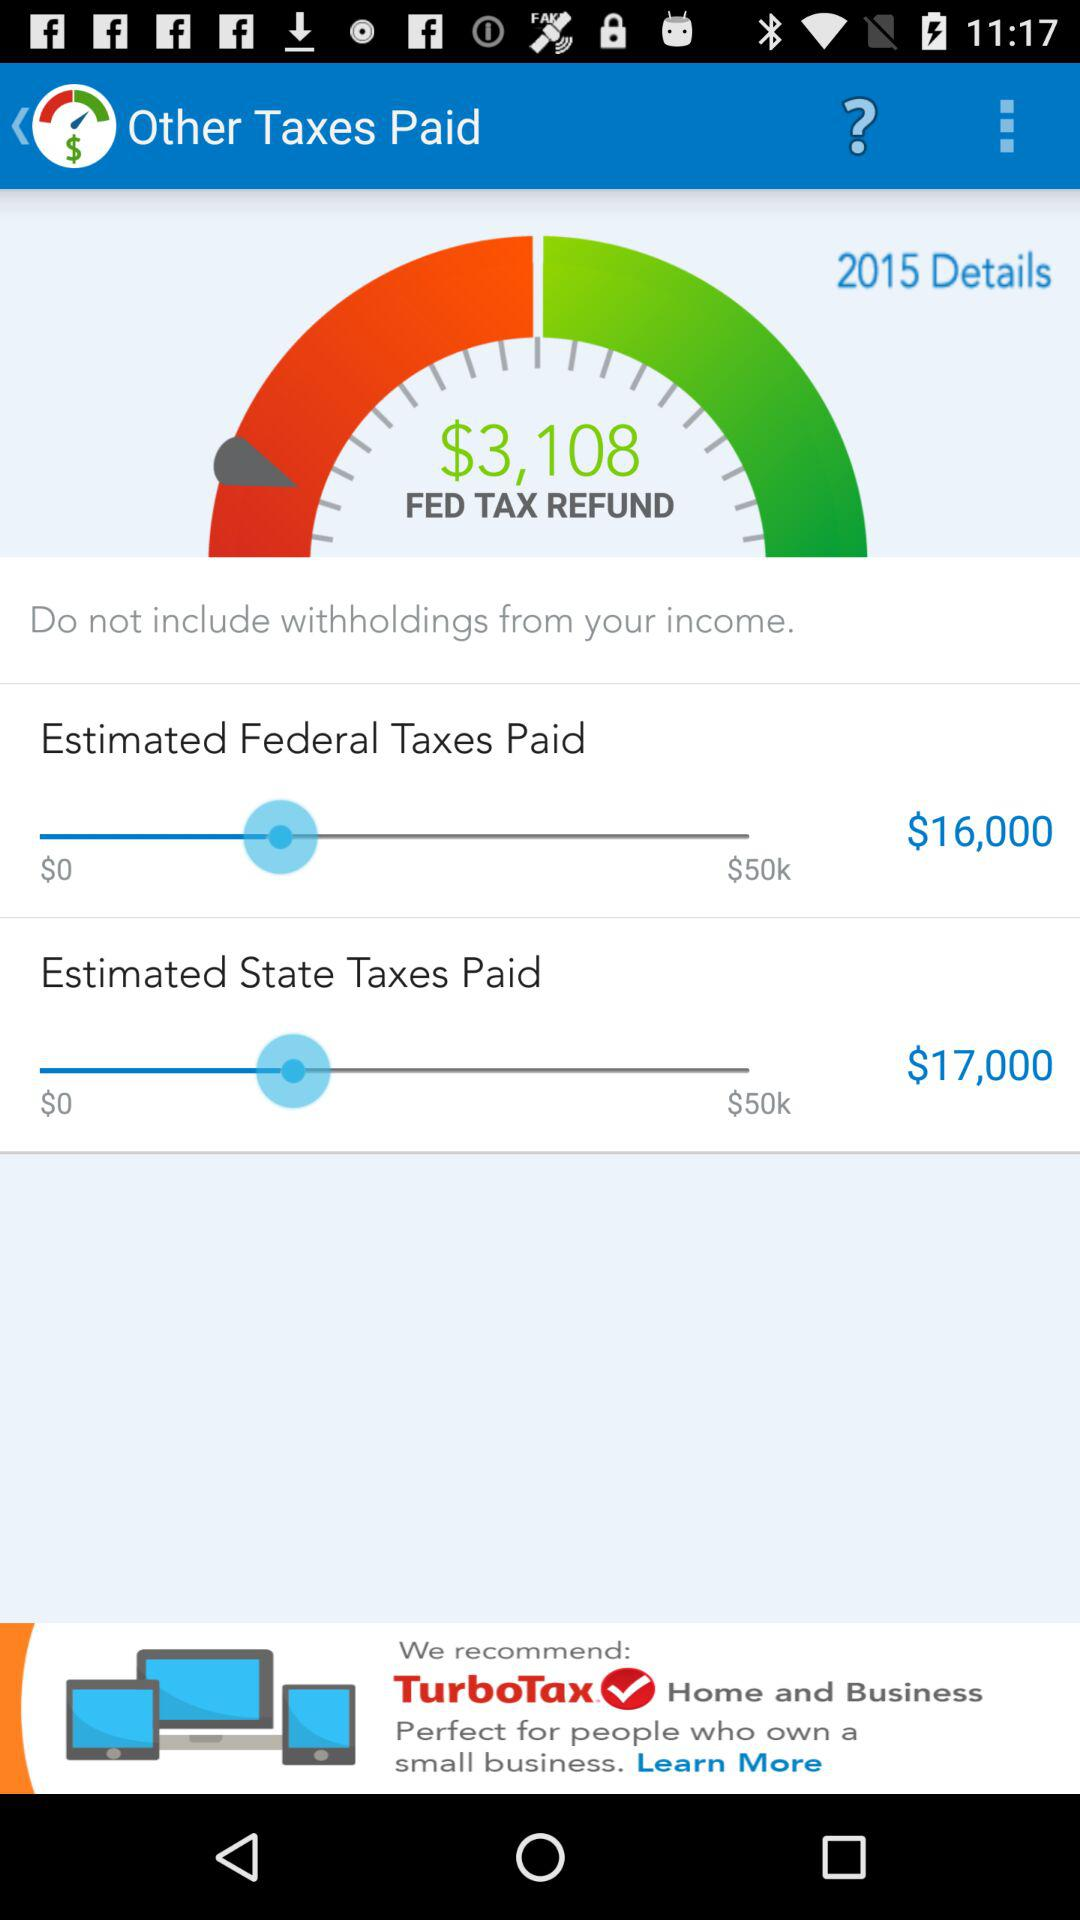What's the set amount for "Estimated State Taxes Paid"? The set amount for "Estimated State Taxes Paid" is $17,000. 